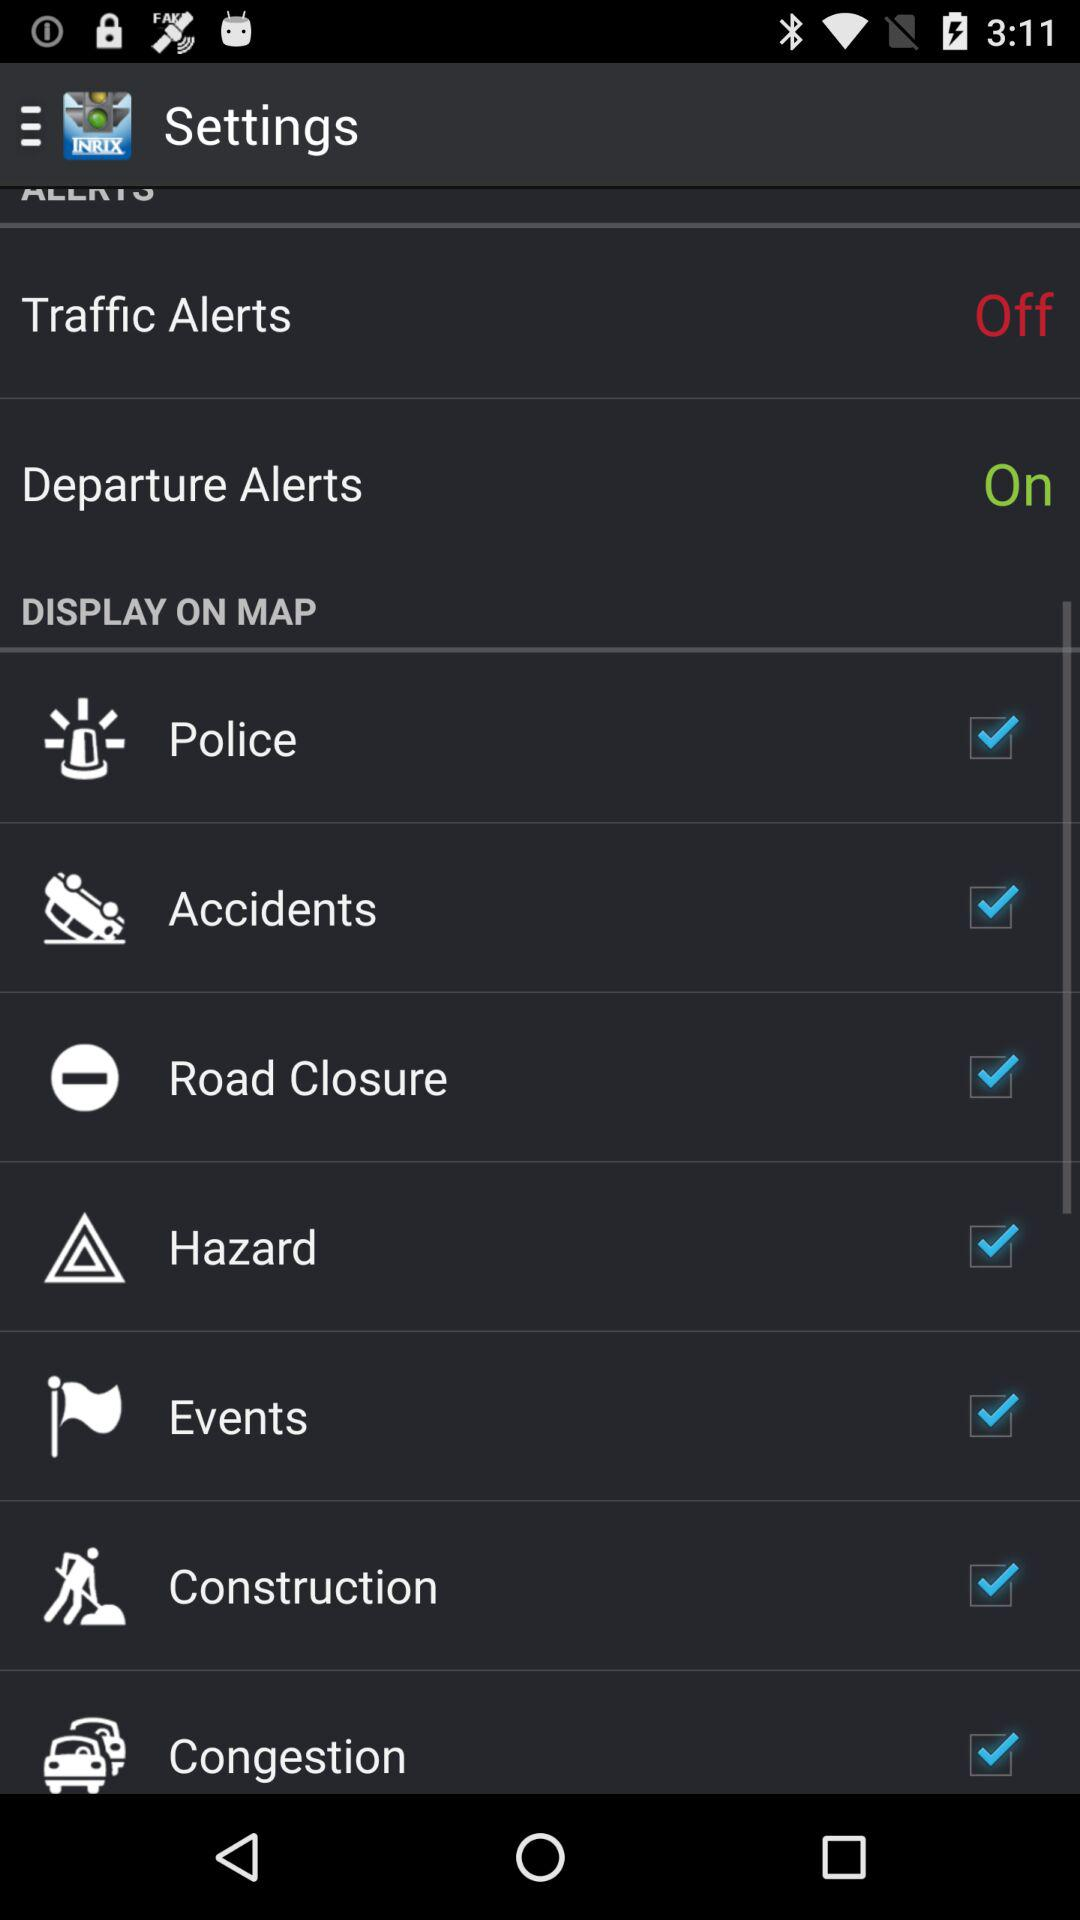What is the status of "Traffic Alerts"? The status of "Traffic Alerts" is "off". 